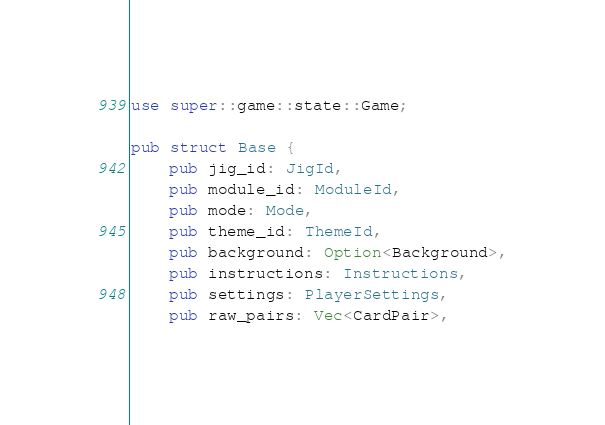Convert code to text. <code><loc_0><loc_0><loc_500><loc_500><_Rust_>
use super::game::state::Game;

pub struct Base {
    pub jig_id: JigId,
    pub module_id: ModuleId,
    pub mode: Mode,
    pub theme_id: ThemeId,
    pub background: Option<Background>,
    pub instructions: Instructions,
    pub settings: PlayerSettings,
    pub raw_pairs: Vec<CardPair>,</code> 